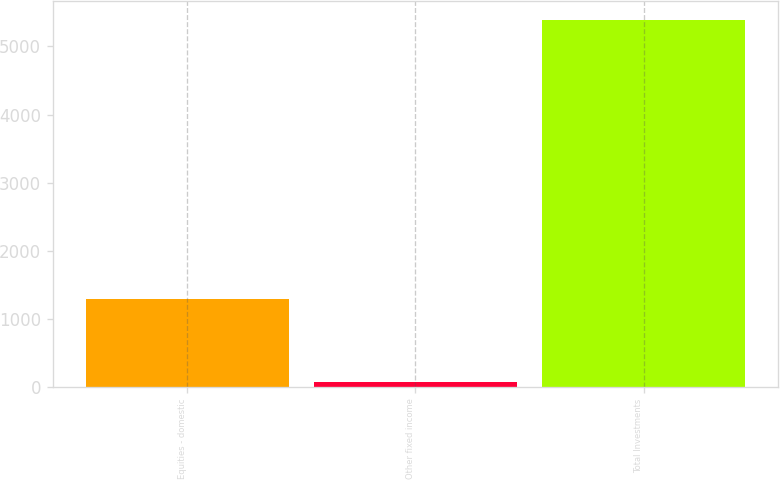Convert chart to OTSL. <chart><loc_0><loc_0><loc_500><loc_500><bar_chart><fcel>Equities - domestic<fcel>Other fixed income<fcel>Total Investments<nl><fcel>1290<fcel>65<fcel>5395<nl></chart> 